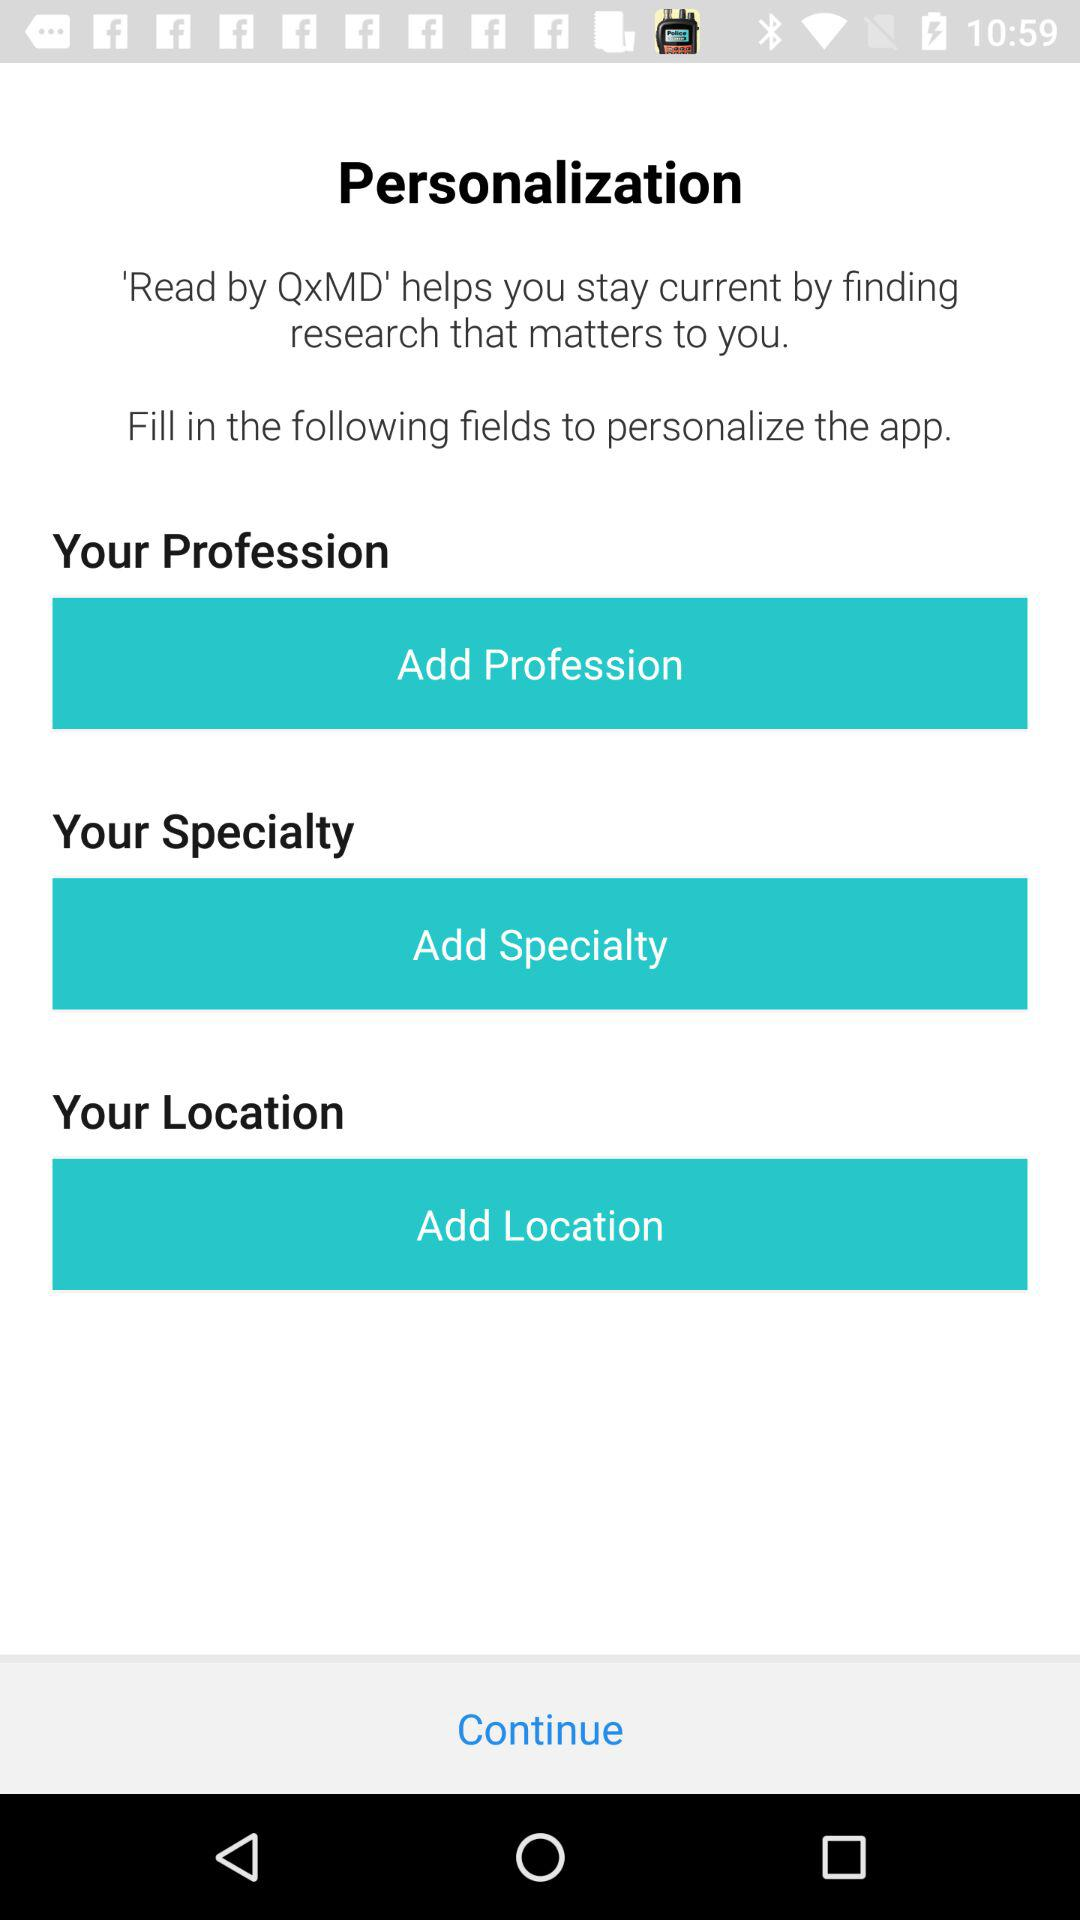How many fields are there in total?
Answer the question using a single word or phrase. 3 